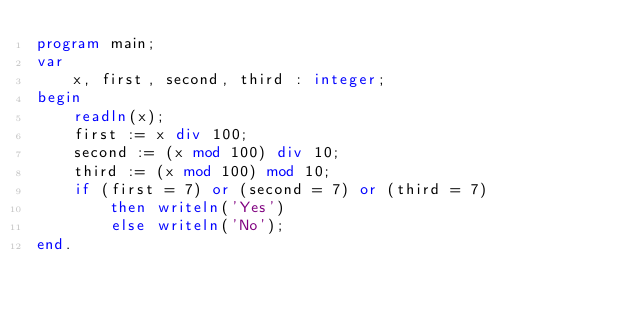<code> <loc_0><loc_0><loc_500><loc_500><_Pascal_>program main;
var 
    x, first, second, third : integer;
begin
    readln(x);
    first := x div 100;
    second := (x mod 100) div 10;
    third := (x mod 100) mod 10;
    if (first = 7) or (second = 7) or (third = 7)
        then writeln('Yes')
        else writeln('No');
end.
</code> 